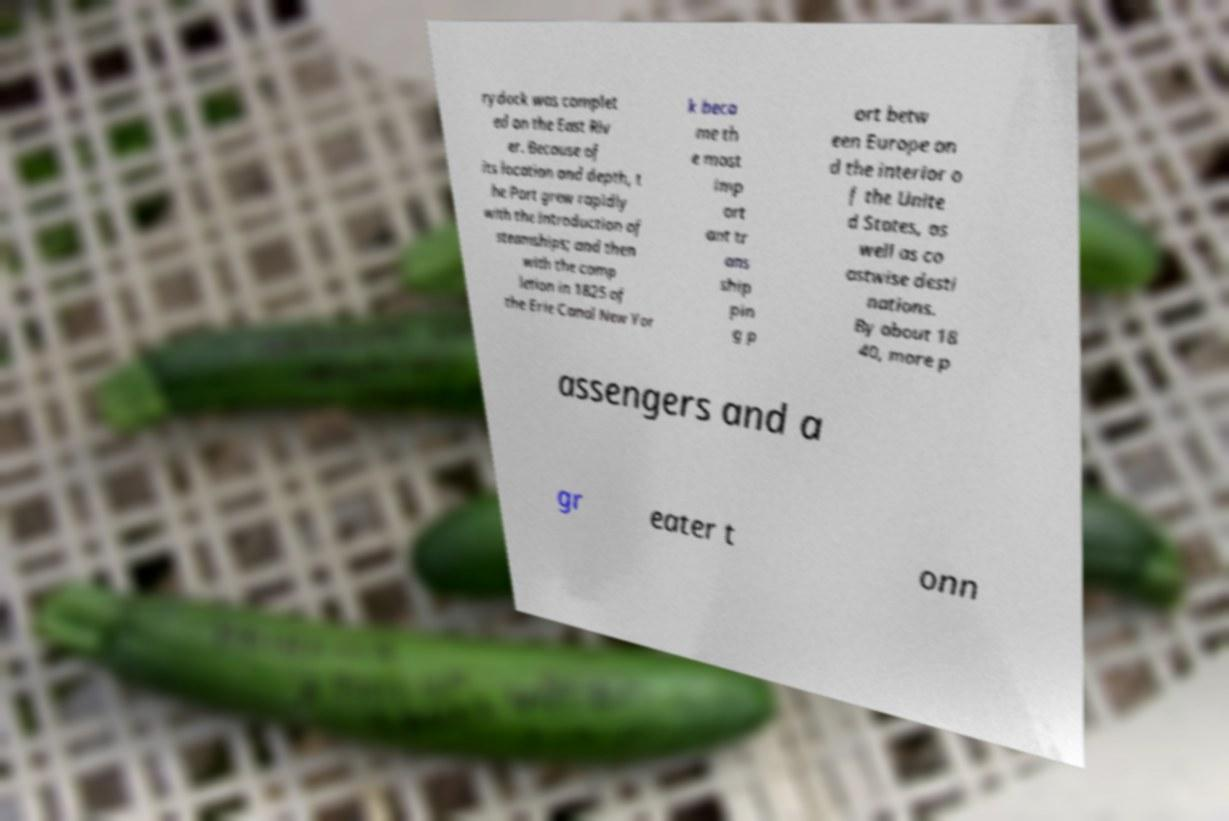For documentation purposes, I need the text within this image transcribed. Could you provide that? rydock was complet ed on the East Riv er. Because of its location and depth, t he Port grew rapidly with the introduction of steamships; and then with the comp letion in 1825 of the Erie Canal New Yor k beca me th e most imp ort ant tr ans ship pin g p ort betw een Europe an d the interior o f the Unite d States, as well as co astwise desti nations. By about 18 40, more p assengers and a gr eater t onn 